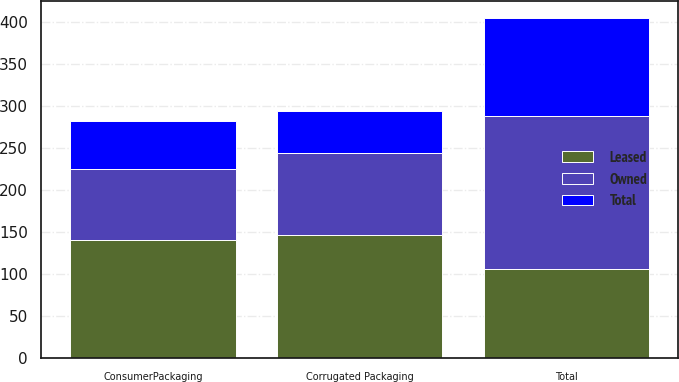Convert chart to OTSL. <chart><loc_0><loc_0><loc_500><loc_500><stacked_bar_chart><ecel><fcel>Corrugated Packaging<fcel>ConsumerPackaging<fcel>Total<nl><fcel>Owned<fcel>97<fcel>84<fcel>181<nl><fcel>Total<fcel>50<fcel>57<fcel>117<nl><fcel>Leased<fcel>147<fcel>141<fcel>107<nl></chart> 